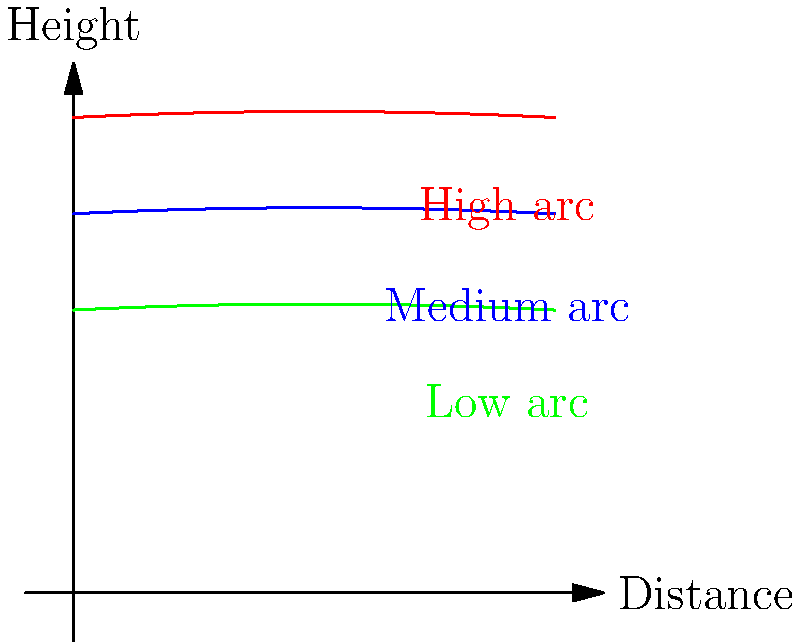Analyze the arc diagrams representing different shooting techniques in basketball. Which trajectory is most likely to result in a higher shooting percentage for long-range shots, and why would this be advantageous against our rival team's defensive strategy? To answer this question, let's analyze the arc diagrams step-by-step:

1. The diagram shows three different shot trajectories: high (red), medium (blue), and low (green) arcs.

2. For long-range shots, the high arc (red) is generally considered the most effective for several reasons:

   a) Greater angle of entry: A higher arc creates a steeper angle as the ball approaches the hoop, increasing the effective size of the target.
   
   b) Reduced rim deflections: The steeper angle of entry reduces the chance of the ball bouncing off the rim.
   
   c) Clearing defenders: A higher arc is more likely to clear the outstretched hands of defenders.

3. The equation for the arc can be represented as:

   $$y = -a(x-h)^2 + k$$

   where $(h,k)$ is the vertex of the parabola and $a$ controls the steepness.

4. The high arc has a larger $k$ value, resulting in a higher peak and steeper descent.

5. Advantages against the rival team's defensive strategy:

   a) Harder to block: The higher release point and steeper trajectory make it more difficult for defenders to block the shot.
   
   b) Forces defensive adjustments: Defenders may need to play closer to shooters, potentially opening up driving lanes for teammates.
   
   c) Increases effective range: Players can shoot from further out while maintaining accuracy, stretching the defense.

6. However, it's important to note that the optimal arc can vary based on individual player mechanics and shooting distance. The high arc technique requires more strength and precision, which players must develop through practice.
Answer: High arc trajectory; steeper angle of entry, reduced rim deflections, and ability to clear defenders. 